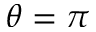Convert formula to latex. <formula><loc_0><loc_0><loc_500><loc_500>\theta = \pi</formula> 